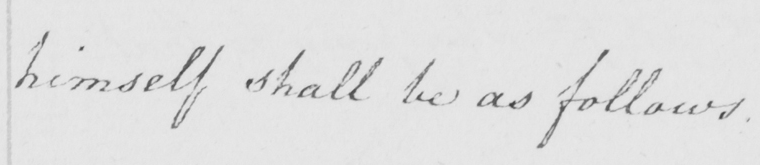Please transcribe the handwritten text in this image. himself shall be as follows . 